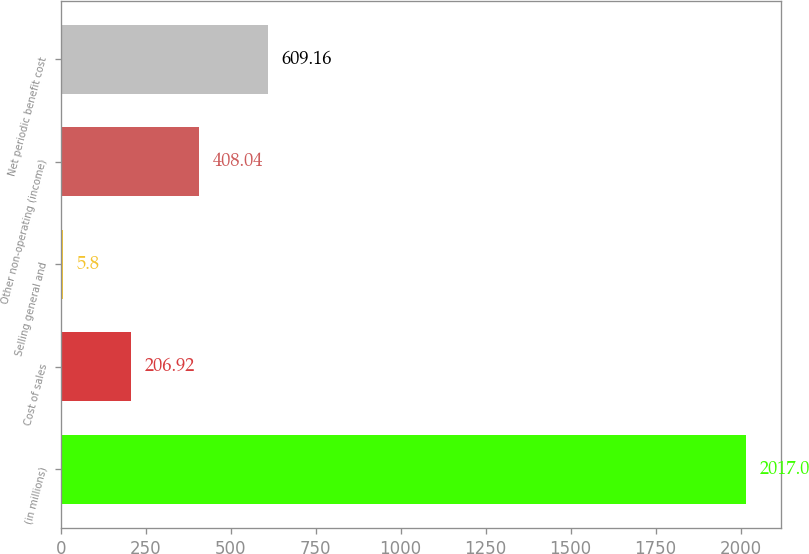Convert chart to OTSL. <chart><loc_0><loc_0><loc_500><loc_500><bar_chart><fcel>(in millions)<fcel>Cost of sales<fcel>Selling general and<fcel>Other non-operating (income)<fcel>Net periodic benefit cost<nl><fcel>2017<fcel>206.92<fcel>5.8<fcel>408.04<fcel>609.16<nl></chart> 